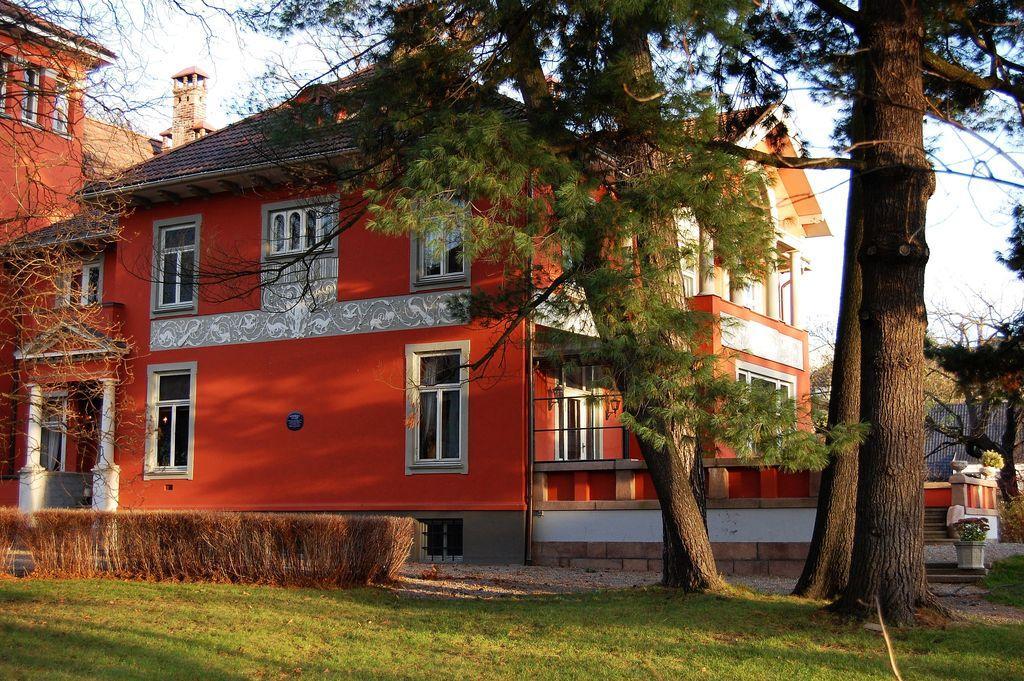In one or two sentences, can you explain what this image depicts? In this image we can see buildings, windows, there are plants, trees, also we can see the sky. 